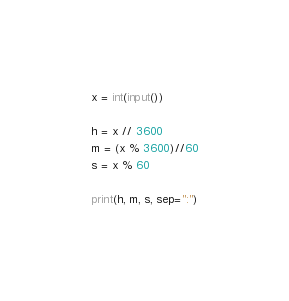Convert code to text. <code><loc_0><loc_0><loc_500><loc_500><_Python_>x = int(input())

h = x // 3600
m = (x % 3600)//60
s = x % 60

print(h, m, s, sep=":")

</code> 